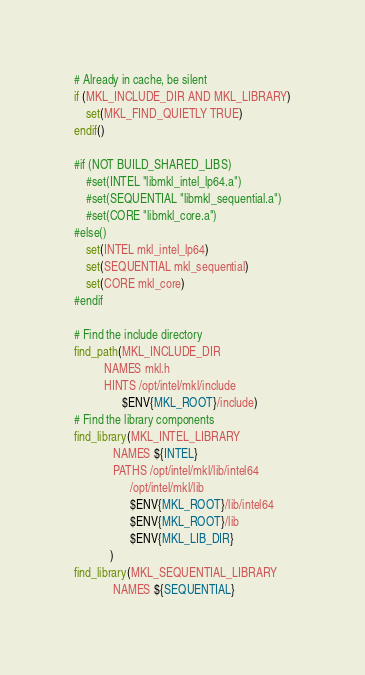Convert code to text. <code><loc_0><loc_0><loc_500><loc_500><_CMake_># Already in cache, be silent
if (MKL_INCLUDE_DIR AND MKL_LIBRARY)
    set(MKL_FIND_QUIETLY TRUE)
endif()

#if (NOT BUILD_SHARED_LIBS)
    #set(INTEL "libmkl_intel_lp64.a")
    #set(SEQUENTIAL "libmkl_sequential.a")
    #set(CORE "libmkl_core.a")
#else()
    set(INTEL mkl_intel_lp64)
    set(SEQUENTIAL mkl_sequential)
    set(CORE mkl_core)
#endif

# Find the include directory
find_path(MKL_INCLUDE_DIR
          NAMES mkl.h
          HINTS /opt/intel/mkl/include
                $ENV{MKL_ROOT}/include)
# Find the library components
find_library(MKL_INTEL_LIBRARY
             NAMES ${INTEL}
             PATHS /opt/intel/mkl/lib/intel64
                   /opt/intel/mkl/lib 
                   $ENV{MKL_ROOT}/lib/intel64
                   $ENV{MKL_ROOT}/lib
                   $ENV{MKL_LIB_DIR}
            )
find_library(MKL_SEQUENTIAL_LIBRARY
             NAMES ${SEQUENTIAL}</code> 